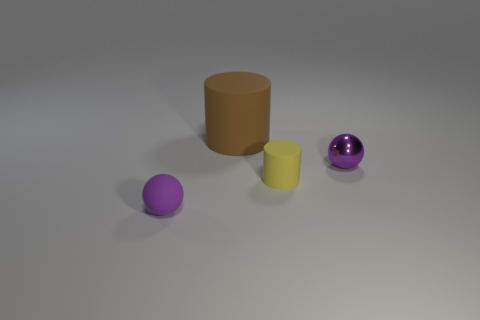Add 2 small green shiny cubes. How many objects exist? 6 Add 3 cyan cylinders. How many cyan cylinders exist? 3 Subtract 0 blue cubes. How many objects are left? 4 Subtract all large brown things. Subtract all tiny balls. How many objects are left? 1 Add 4 small cylinders. How many small cylinders are left? 5 